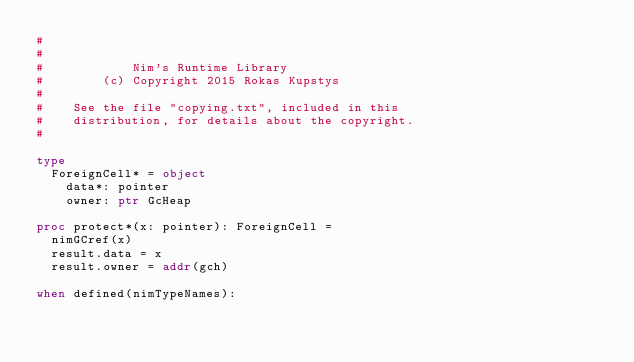Convert code to text. <code><loc_0><loc_0><loc_500><loc_500><_Nim_>#
#
#            Nim's Runtime Library
#        (c) Copyright 2015 Rokas Kupstys
#
#    See the file "copying.txt", included in this
#    distribution, for details about the copyright.
#

type
  ForeignCell* = object
    data*: pointer
    owner: ptr GcHeap

proc protect*(x: pointer): ForeignCell =
  nimGCref(x)
  result.data = x
  result.owner = addr(gch)

when defined(nimTypeNames):</code> 